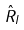Convert formula to latex. <formula><loc_0><loc_0><loc_500><loc_500>\hat { R } _ { I }</formula> 